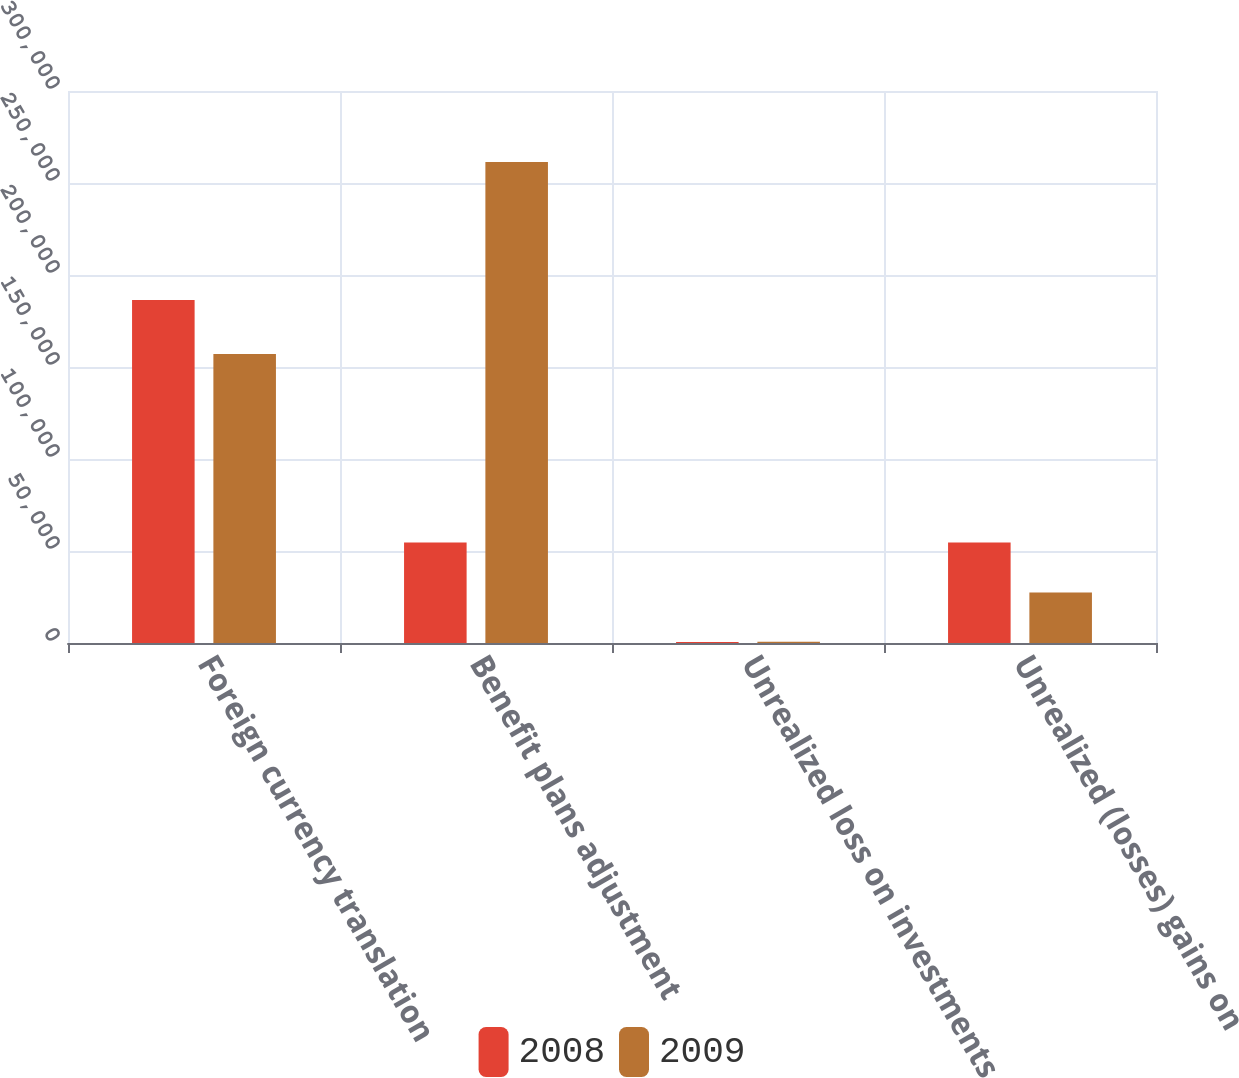Convert chart. <chart><loc_0><loc_0><loc_500><loc_500><stacked_bar_chart><ecel><fcel>Foreign currency translation<fcel>Benefit plans adjustment<fcel>Unrealized loss on investments<fcel>Unrealized (losses) gains on<nl><fcel>2008<fcel>186447<fcel>54593<fcel>581<fcel>54593<nl><fcel>2009<fcel>157089<fcel>261457<fcel>622<fcel>27480<nl></chart> 